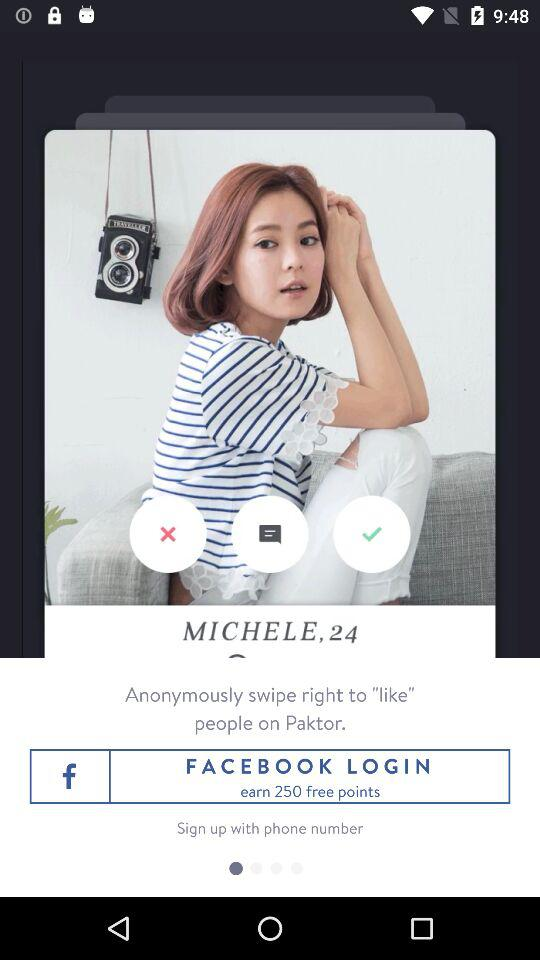Through which application can we log in? You can log in through "FACEBOOK". 